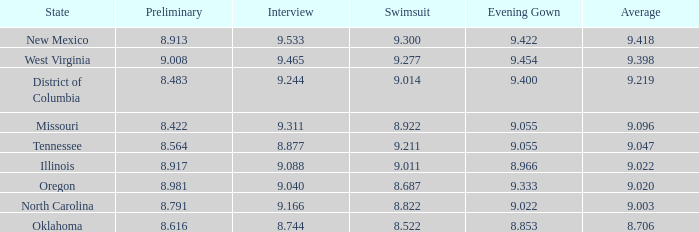What is the swimsuit designed for oregon? 8.687. 